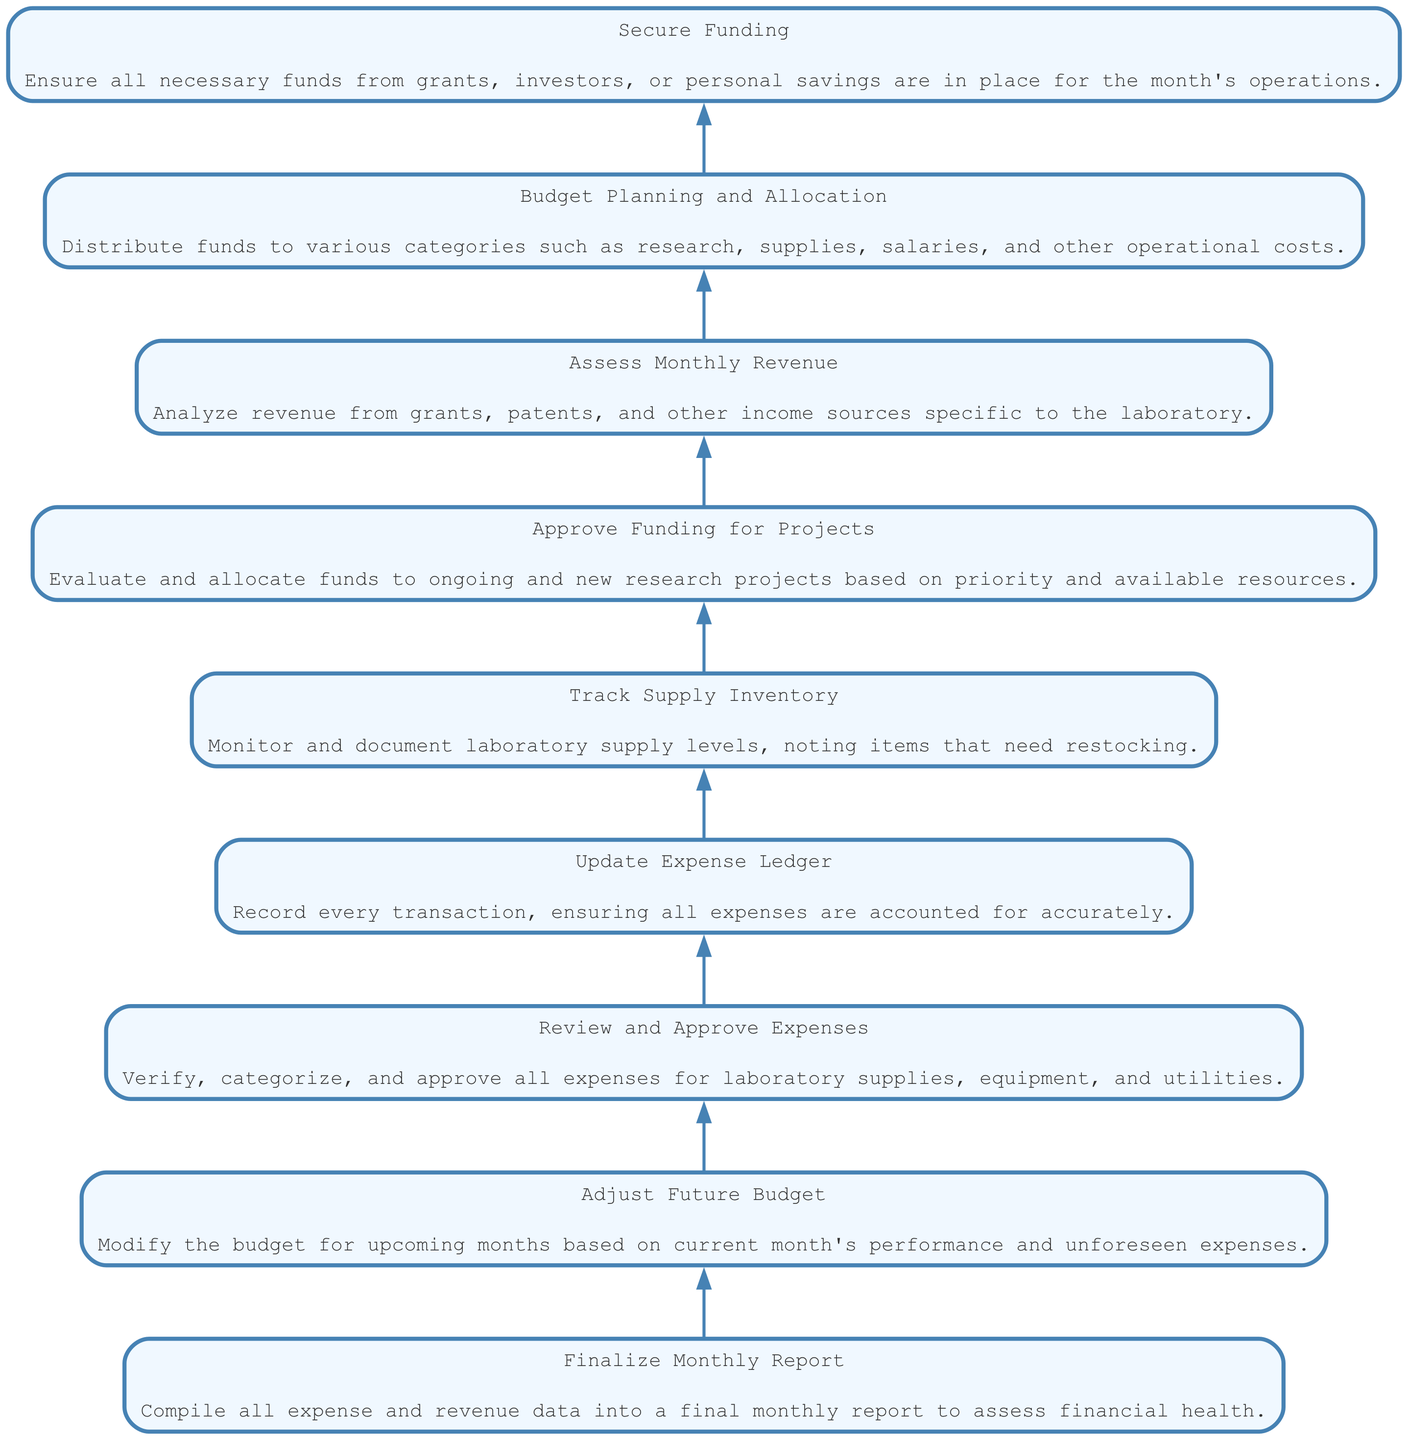What's the final step in the budget management process? The diagram indicates that the final step is "Finalize Monthly Report," which compiles all expense and revenue data.
Answer: Finalize Monthly Report How many nodes are present in the diagram? Counting each element in the flowchart, there are a total of nine nodes that represent different steps in managing the budget.
Answer: 9 Which step comes directly before "Adjust Future Budget"? Referring to the flow from bottom to top, "Finalize Monthly Report" is the step immediately preceding "Adjust Future Budget."
Answer: Finalize Monthly Report What is the first action in managing the budget? The first action, as represented at the bottom of the flowchart, is "Secure Funding," which ensures necessary funds are in place.
Answer: Secure Funding What category does "Budget Planning and Allocation" fall under? "Budget Planning and Allocation" refers to the distribution of funds, categorizing various expenses such as salaries and supplies. This is a fundamental step in financial management.
Answer: Distribution of funds Explain the connection between "Assess Monthly Revenue" and "Adjust Future Budget." "Assess Monthly Revenue" provides insights into the financial status by analyzing income sources. This assessment influences "Adjust Future Budget," which modifies future allocations based on the current month's performance.
Answer: Financial status influences adjustments What is the penultimate action before the final report? The penultimate action, coming immediately before the final report, is "Review and Approve Expenses," where all expenses are verified and approved.
Answer: Review and Approve Expenses How does the step "Approve Funding for Projects" connect to budget allocation? "Approve Funding for Projects" evaluates and allocates funds to projects, directly linking project funding decisions to the overall "Budget Planning and Allocation" process, thereby influencing how resources are distributed.
Answer: Links project funding to resource distribution 